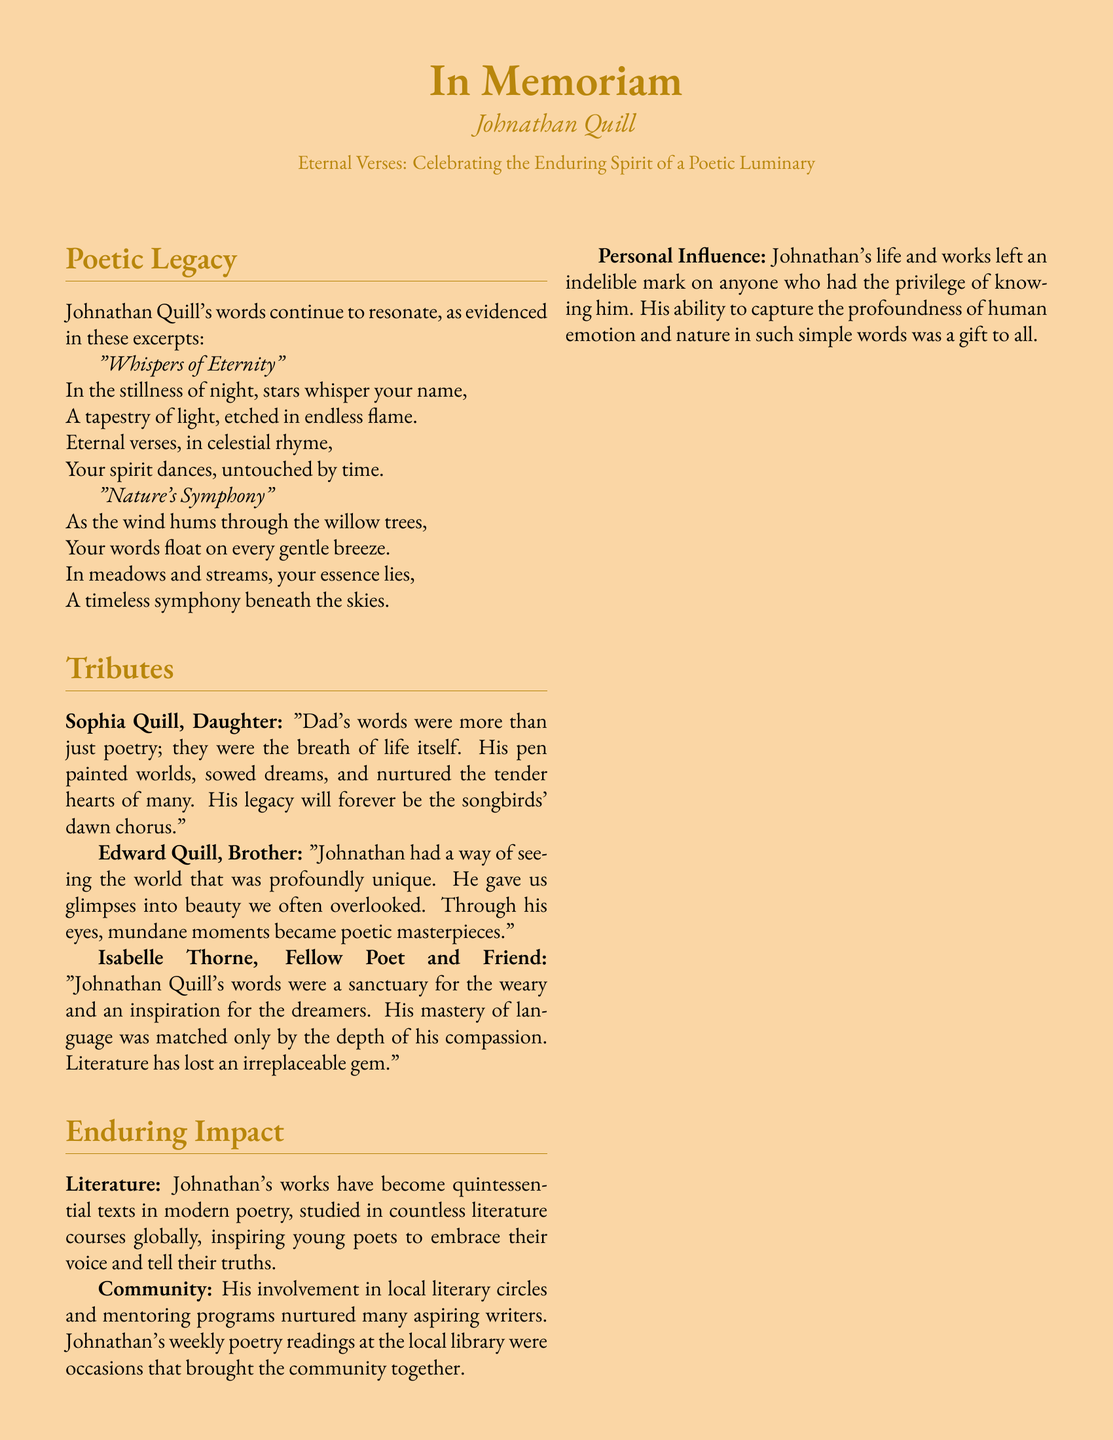What is the name of the author celebrated in the obituary? The document is dedicated to the remembrance of Johnathan Quill, as indicated at the top of the page.
Answer: Johnathan Quill What is the title of the first poem excerpted in the document? The first poem excerpted is titled "Whispers of Eternity," mentioned under the Poetic Legacy section.
Answer: Whispers of Eternity Who is one of the individuals who paid tribute to Johnathan Quill? The tributes section lists several individuals, including Sophia Quill.
Answer: Sophia Quill What is one of the key themes mentioned in the tributes? Edward Quill comments on Johnathan's unique perspective and ability to capture beauty, which highlights his impactful view of the world.
Answer: Unique perspective In what venues did Johnathan Quill engage with the community? The document notes his involvement in local literary circles and mentions his weekly poetry readings at a local library, emphasizing community engagement.
Answer: Local library What metaphor is used in the last few lines of the document to describe Johnathan's spirit? The concluding lines convey that Johnathan's spirit lives on in natural elements like wind and sunlight, using metaphors to signify his enduring presence.
Answer: Natural elements What impact did Johnathan Quill’s works have on literature? The text states that his works have become quintessential texts in modern poetry and are studied in various literature courses worldwide.
Answer: Quintessential texts Who described Johnathan's words as a sanctuary for the weary? The tribute from Isabelle Thorne specifically mentions how Johnathan's words served as a sanctuary for those in need.
Answer: Isabelle Thorne 